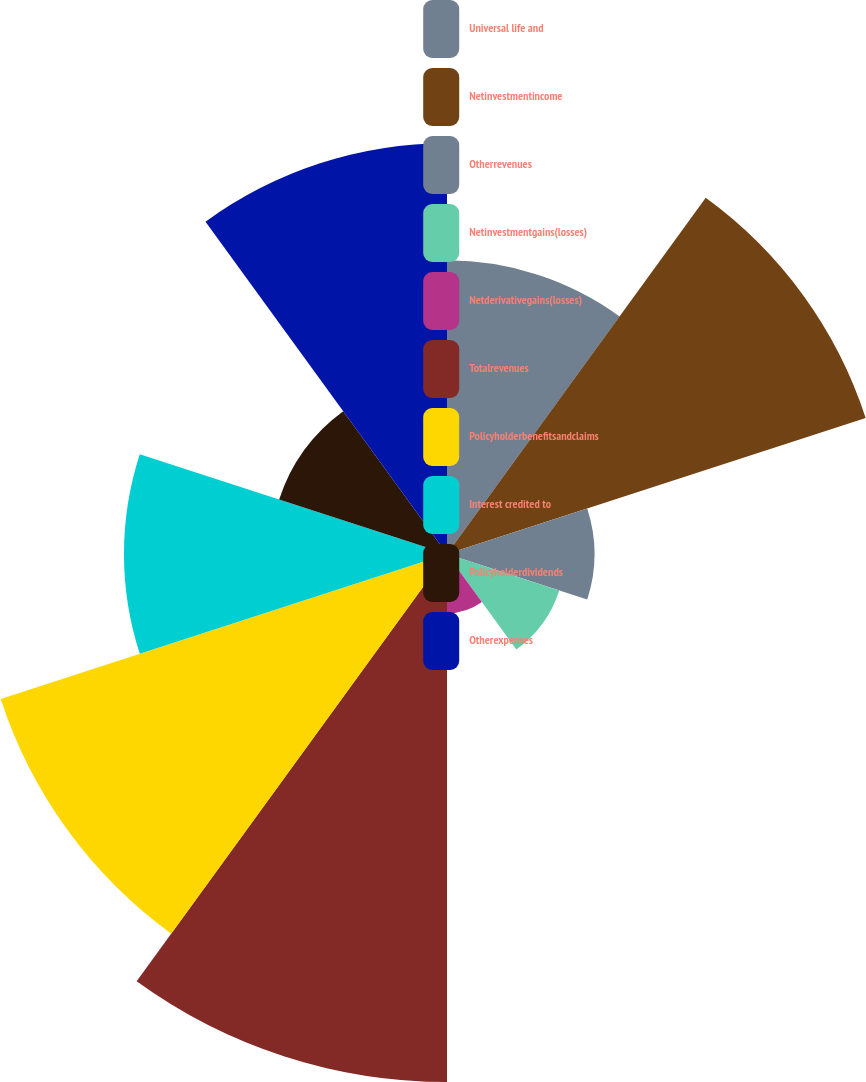Convert chart to OTSL. <chart><loc_0><loc_0><loc_500><loc_500><pie_chart><fcel>Universal life and<fcel>Netinvestmentincome<fcel>Otherrevenues<fcel>Netinvestmentgains(losses)<fcel>Netderivativegains(losses)<fcel>Totalrevenues<fcel>Policyholderbenefitsandclaims<fcel>Interest credited to<fcel>Policyholderdividends<fcel>Otherexpenses<nl><fcel>9.9%<fcel>14.84%<fcel>4.97%<fcel>3.98%<fcel>2.0%<fcel>17.8%<fcel>15.82%<fcel>10.89%<fcel>5.95%<fcel>13.85%<nl></chart> 